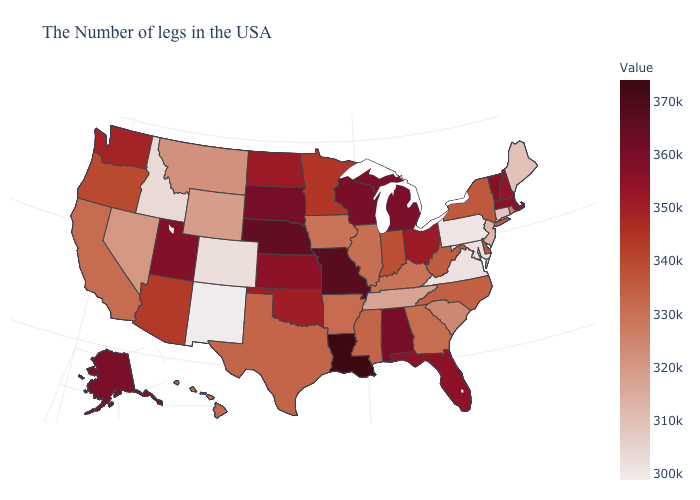Which states have the lowest value in the South?
Be succinct. Virginia. Among the states that border New York , does Massachusetts have the highest value?
Write a very short answer. No. Which states hav the highest value in the West?
Answer briefly. Alaska. 